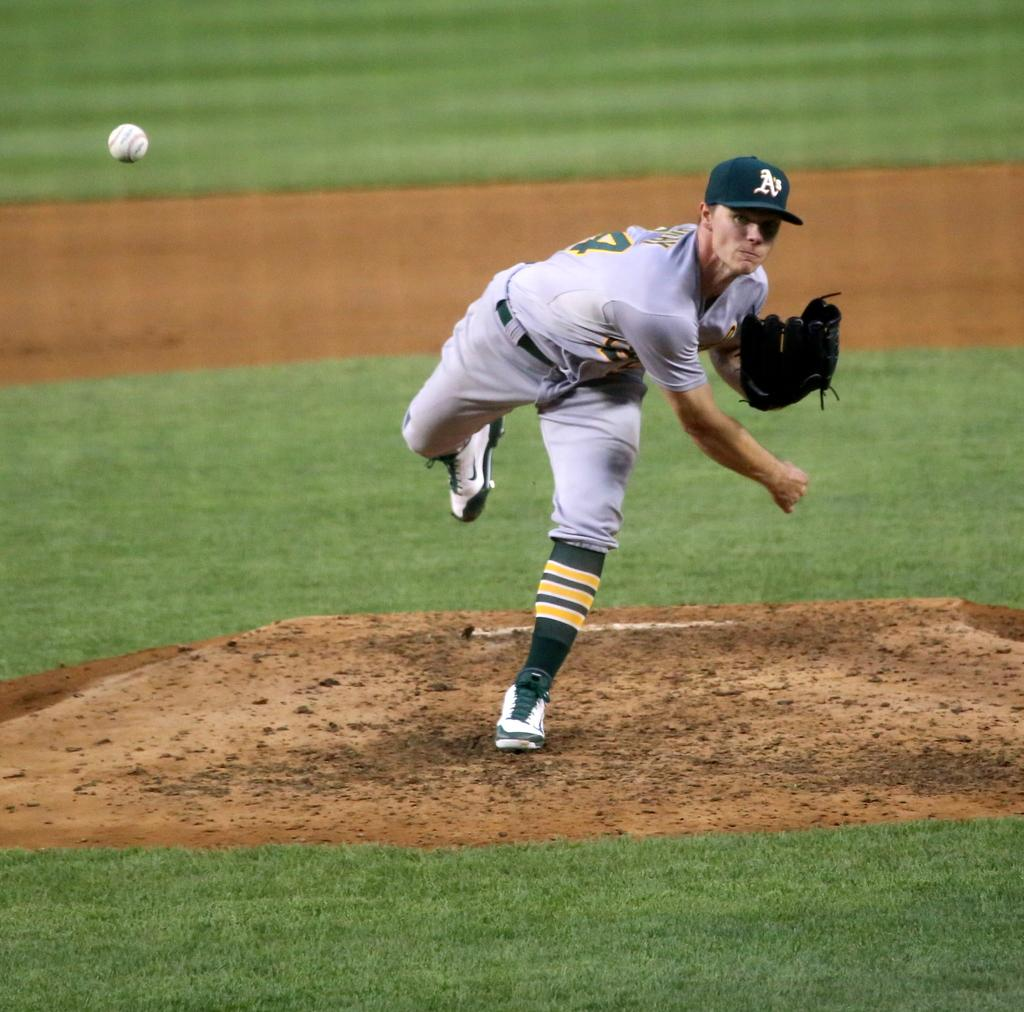<image>
Write a terse but informative summary of the picture. A pitcher in an A's hat throws the ball. 